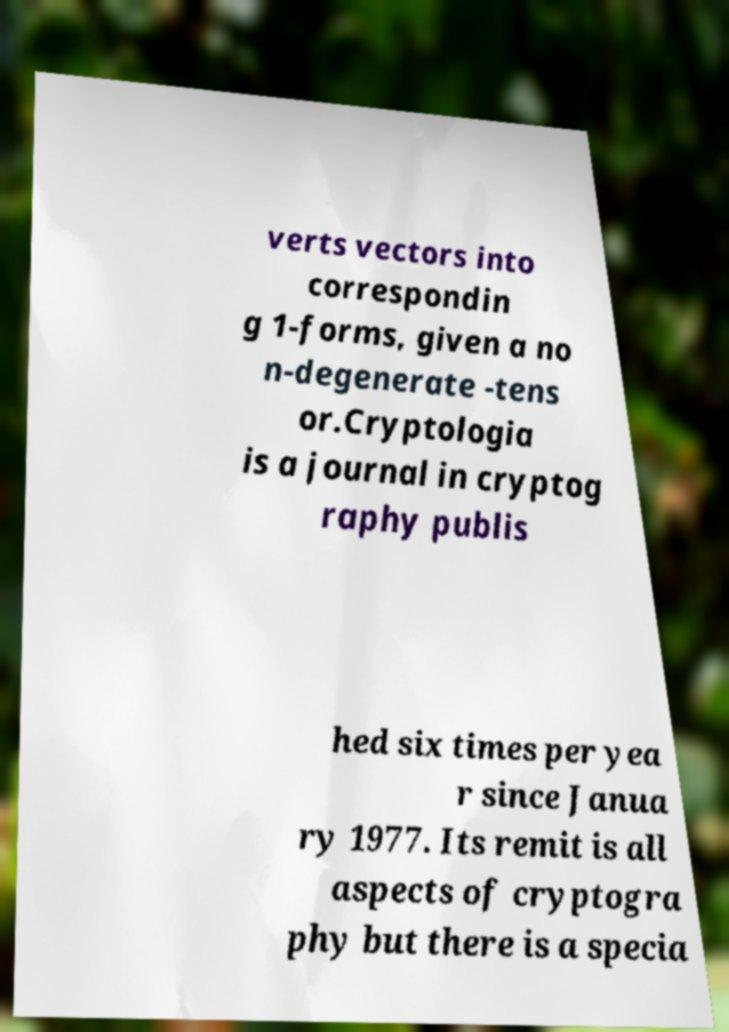Can you read and provide the text displayed in the image?This photo seems to have some interesting text. Can you extract and type it out for me? verts vectors into correspondin g 1-forms, given a no n-degenerate -tens or.Cryptologia is a journal in cryptog raphy publis hed six times per yea r since Janua ry 1977. Its remit is all aspects of cryptogra phy but there is a specia 